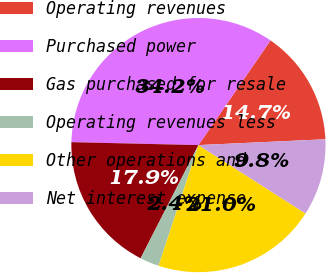Convert chart. <chart><loc_0><loc_0><loc_500><loc_500><pie_chart><fcel>Operating revenues<fcel>Purchased power<fcel>Gas purchased for resale<fcel>Operating revenues less<fcel>Other operations and<fcel>Net interest expense<nl><fcel>14.67%<fcel>34.23%<fcel>17.85%<fcel>2.44%<fcel>21.03%<fcel>9.78%<nl></chart> 